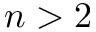Convert formula to latex. <formula><loc_0><loc_0><loc_500><loc_500>n > 2</formula> 